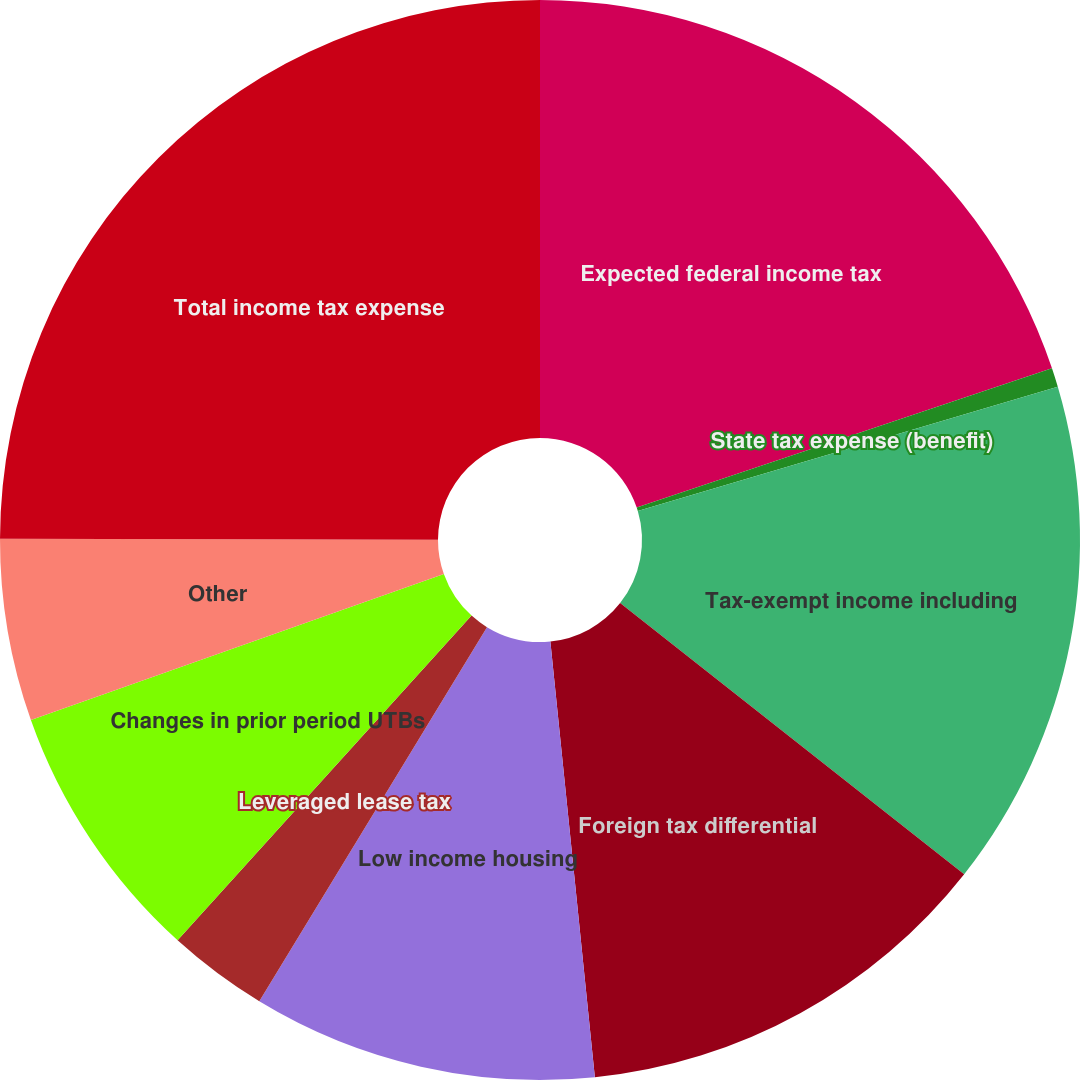<chart> <loc_0><loc_0><loc_500><loc_500><pie_chart><fcel>Expected federal income tax<fcel>State tax expense (benefit)<fcel>Tax-exempt income including<fcel>Foreign tax differential<fcel>Low income housing<fcel>Leveraged lease tax<fcel>Changes in prior period UTBs<fcel>Other<fcel>Total income tax expense<nl><fcel>19.85%<fcel>0.57%<fcel>15.2%<fcel>12.76%<fcel>10.32%<fcel>3.01%<fcel>7.88%<fcel>5.45%<fcel>24.96%<nl></chart> 